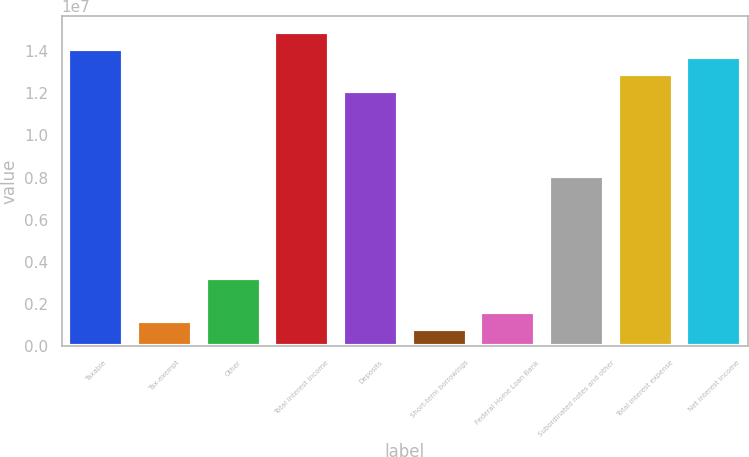Convert chart to OTSL. <chart><loc_0><loc_0><loc_500><loc_500><bar_chart><fcel>Taxable<fcel>Tax-exempt<fcel>Other<fcel>Total interest income<fcel>Deposits<fcel>Short-term borrowings<fcel>Federal Home Loan Bank<fcel>Subordinated notes and other<fcel>Total interest expense<fcel>Net interest income<nl><fcel>1.4117e+07<fcel>1.21004e+06<fcel>3.22676e+06<fcel>1.49237e+07<fcel>1.21003e+07<fcel>806694<fcel>1.61338e+06<fcel>8.06688e+06<fcel>1.2907e+07<fcel>1.37137e+07<nl></chart> 